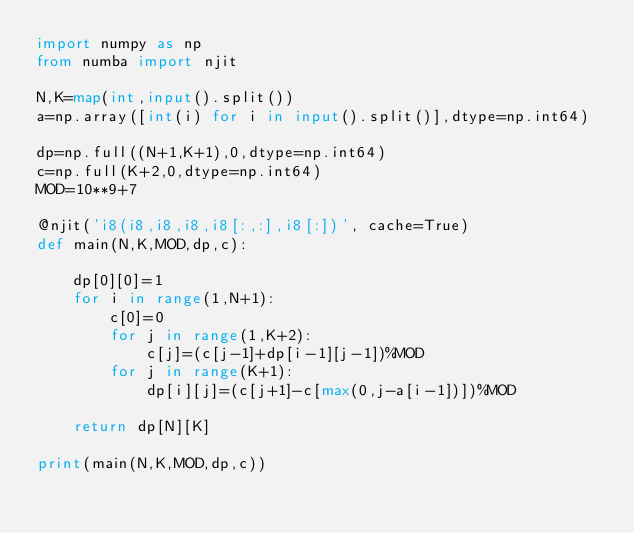<code> <loc_0><loc_0><loc_500><loc_500><_Python_>import numpy as np
from numba import njit

N,K=map(int,input().split())
a=np.array([int(i) for i in input().split()],dtype=np.int64)

dp=np.full((N+1,K+1),0,dtype=np.int64)
c=np.full(K+2,0,dtype=np.int64)
MOD=10**9+7

@njit('i8(i8,i8,i8,i8[:,:],i8[:])', cache=True)
def main(N,K,MOD,dp,c):

    dp[0][0]=1
    for i in range(1,N+1):
        c[0]=0
        for j in range(1,K+2):
            c[j]=(c[j-1]+dp[i-1][j-1])%MOD
        for j in range(K+1):
            dp[i][j]=(c[j+1]-c[max(0,j-a[i-1])])%MOD

    return dp[N][K]

print(main(N,K,MOD,dp,c))
</code> 